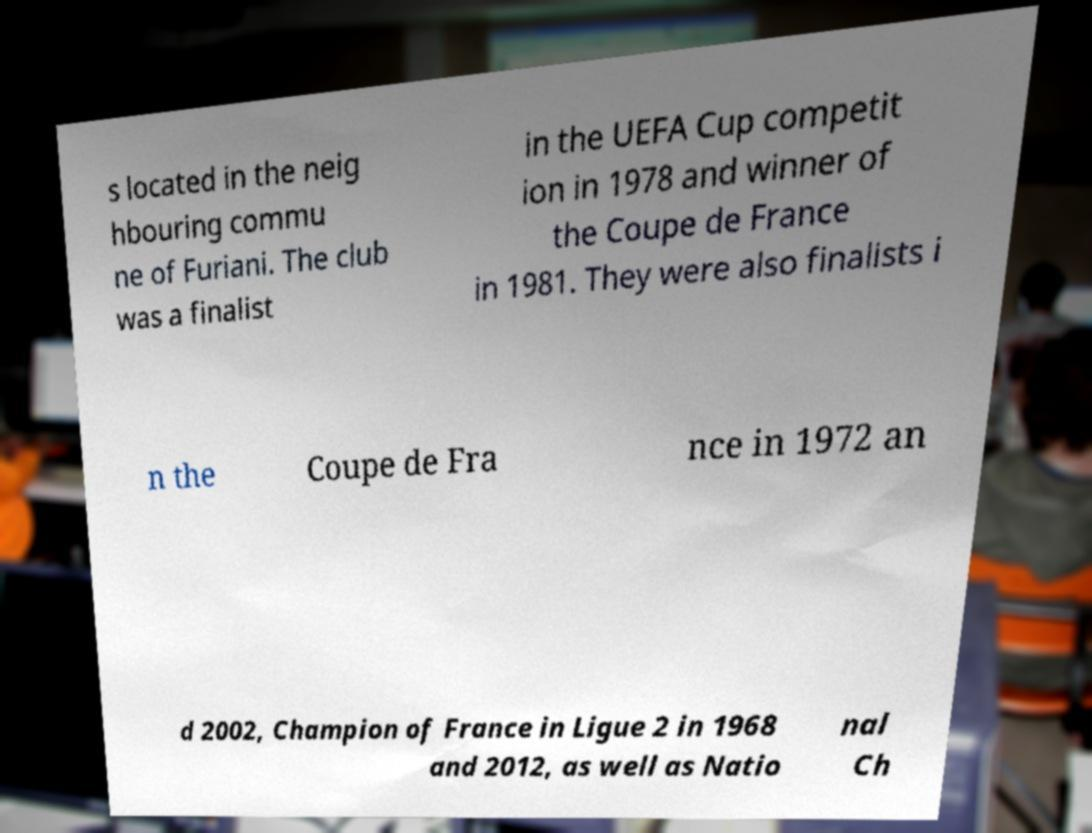Please read and relay the text visible in this image. What does it say? s located in the neig hbouring commu ne of Furiani. The club was a finalist in the UEFA Cup competit ion in 1978 and winner of the Coupe de France in 1981. They were also finalists i n the Coupe de Fra nce in 1972 an d 2002, Champion of France in Ligue 2 in 1968 and 2012, as well as Natio nal Ch 